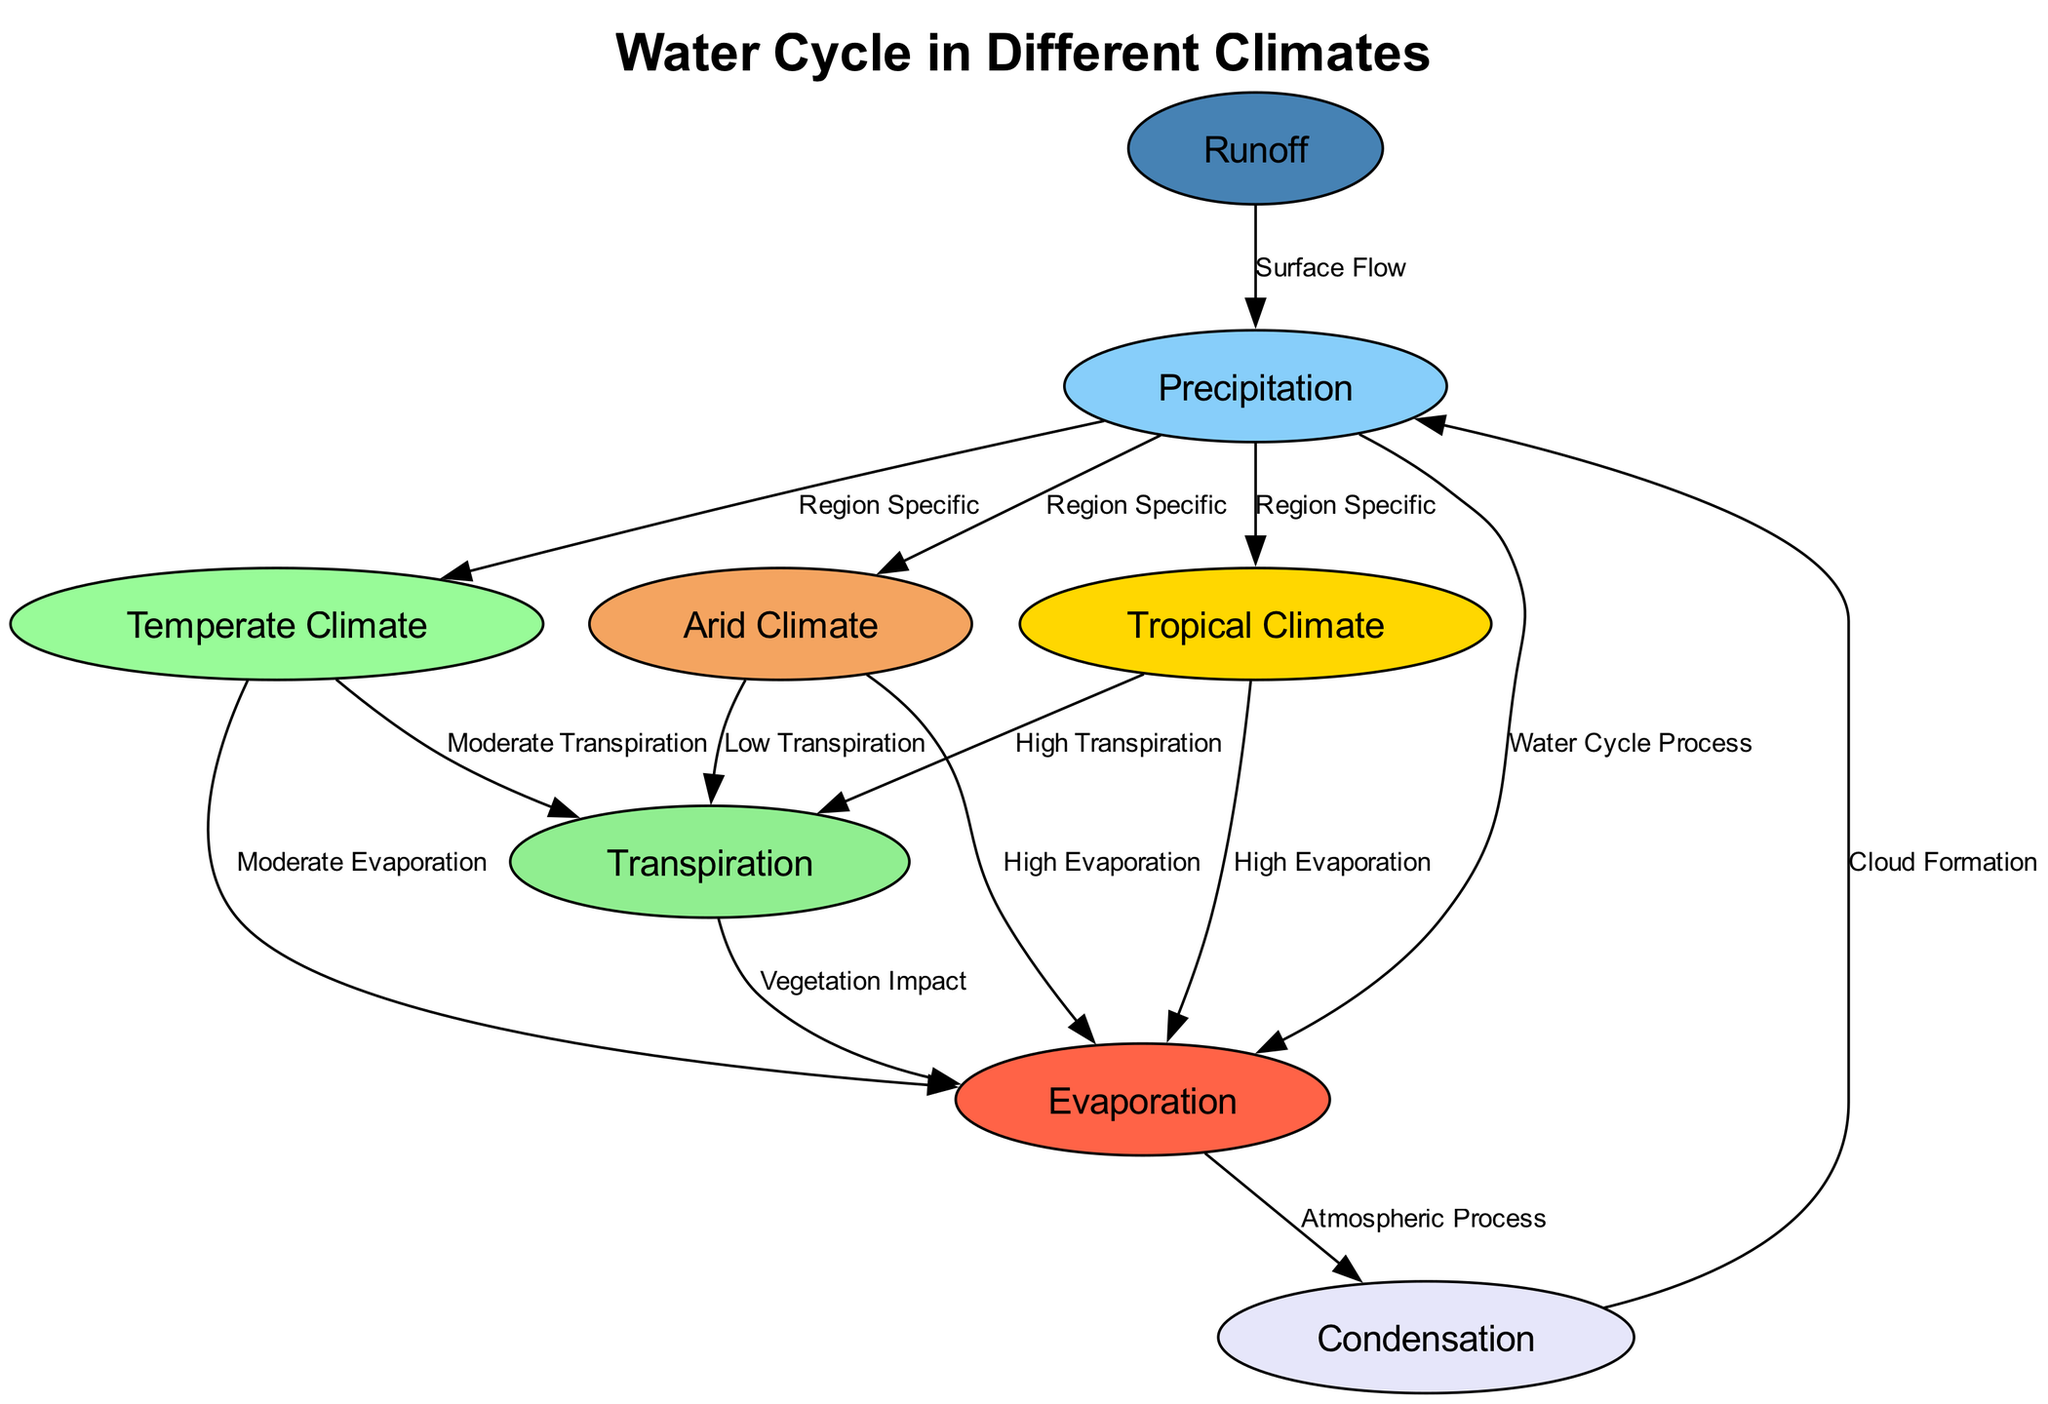What is the label of node 1? The label of node 1 is given directly in the data provided. It states that node 1 corresponds to "Precipitation."
Answer: Precipitation How many nodes are represented in this diagram? To determine the number of nodes, we count the entries listed in the "nodes" section of the data. There are 8 nodes in total.
Answer: 8 Which climate has low precipitation? By reviewing the climates listed, we see that the "Arid Climate" node is associated with low precipitation according to its description.
Answer: Arid Climate What process follows evaporation in the water cycle? The edge relationship in the diagram indicates that condensation follows evaporation. Specifically, from node 2 (Evaporation) to node 3 (Condensation).
Answer: Condensation In which climate is evaporation categorized as high? Both "Tropical Climate" and "Arid Climate" are described in their respective nodes as having high evaporation. By focusing on the direct relationship to evaporation, we identify them.
Answer: Tropical Climate, Arid Climate What is the relationship between transpiration and the Tropical Climate? The diagram indicates a direct edge from the Tropical Climate node (6) to the Transpiration node (4), reflecting that high transpiration occurs in this climate.
Answer: High Transpiration How does runoff relate to precipitation? The data shows there is an edge from the Runoff node (5) to the Precipitation node (1), indicating that runoff is influenced by precipitation, specifically through surface flow.
Answer: Surface Flow What type of diagram is represented here? This is a "Natural Science Diagram," depicting the water cycle across different climates, as specified in the title of the diagram.
Answer: Natural Science Diagram In terms of transpiration, how does the Arid Climate compare to the Tropical Climate? According to the edges, the Arid Climate is associated with low transpiration, while the Tropical Climate is associated with high transpiration. This indicates a clear contrast between the two climates regarding the amount of transpiration produced.
Answer: Low Transpiration, High Transpiration 